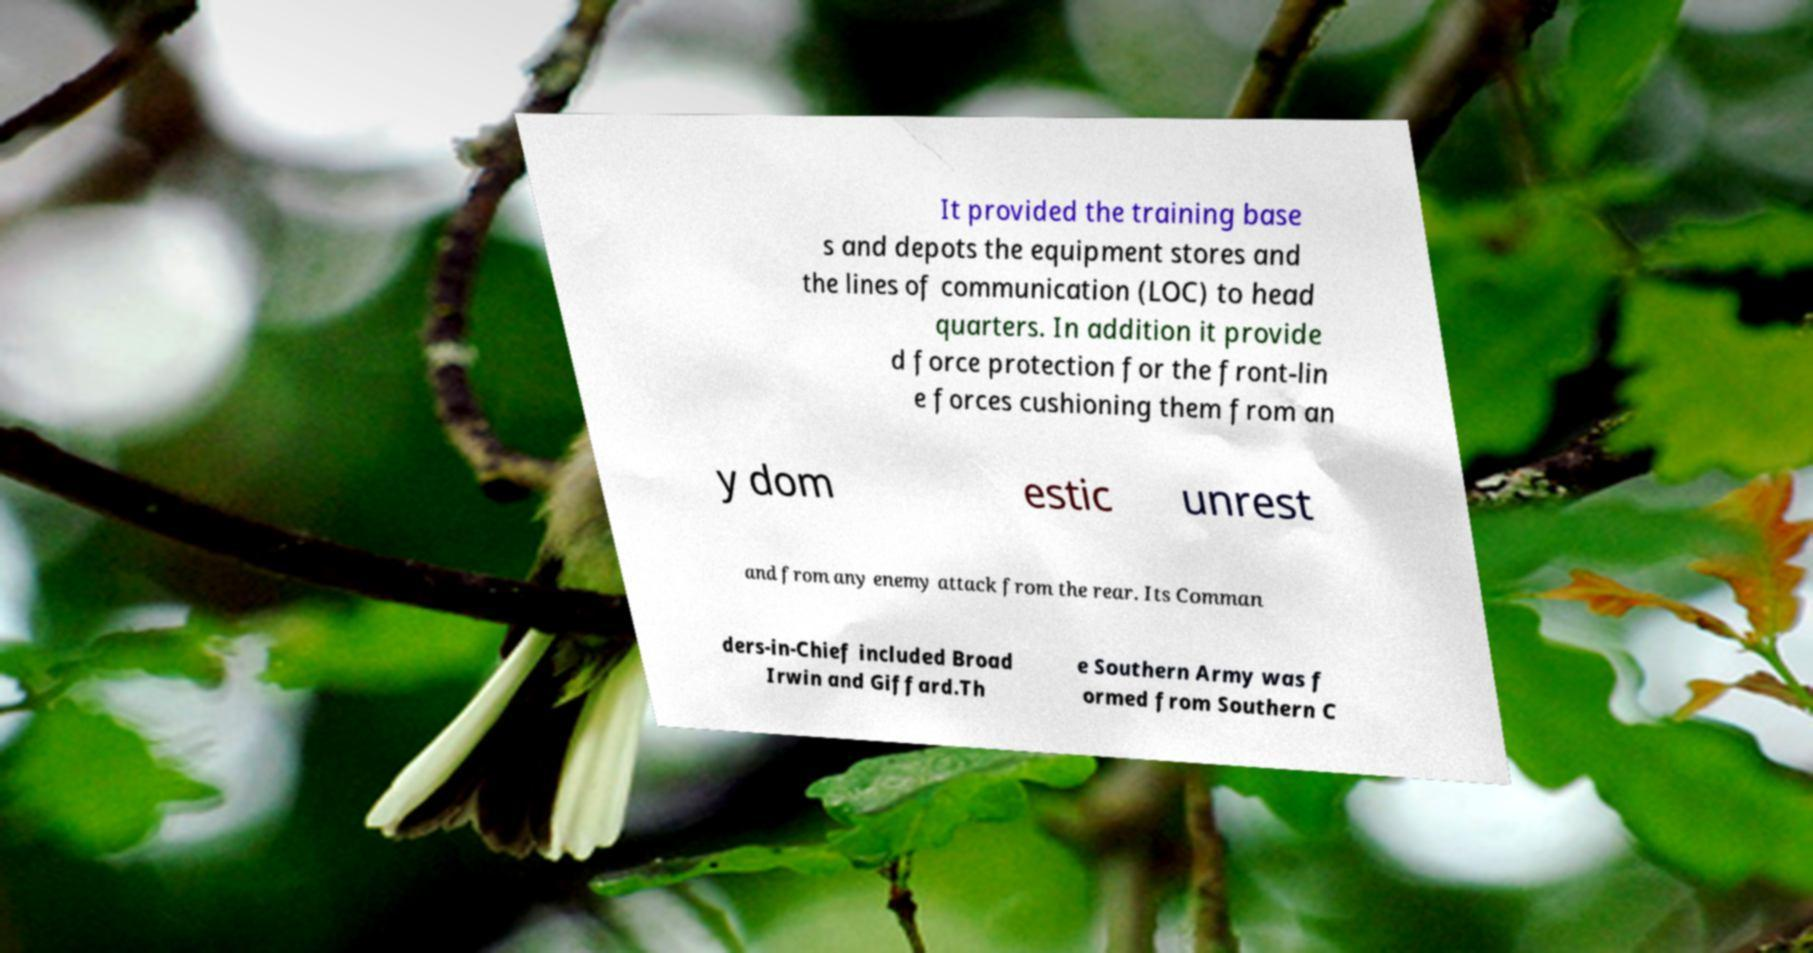Can you read and provide the text displayed in the image?This photo seems to have some interesting text. Can you extract and type it out for me? It provided the training base s and depots the equipment stores and the lines of communication (LOC) to head quarters. In addition it provide d force protection for the front-lin e forces cushioning them from an y dom estic unrest and from any enemy attack from the rear. Its Comman ders-in-Chief included Broad Irwin and Giffard.Th e Southern Army was f ormed from Southern C 